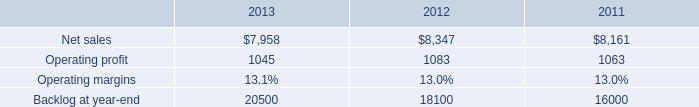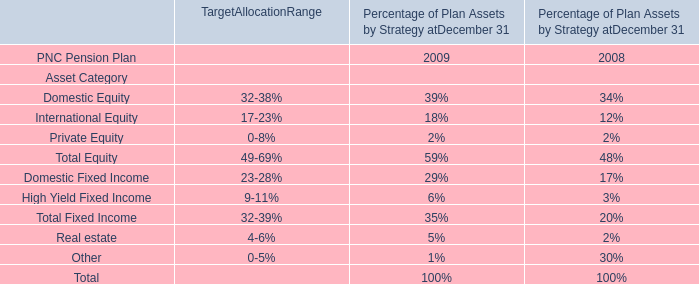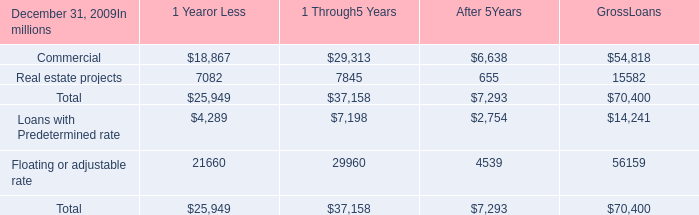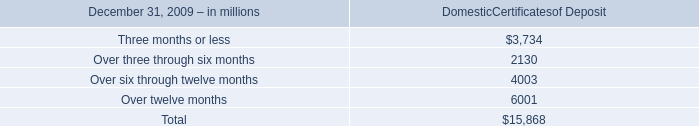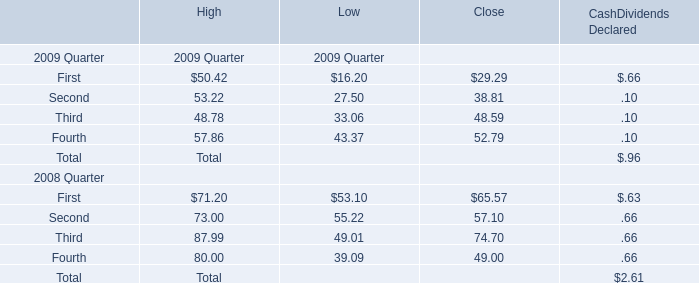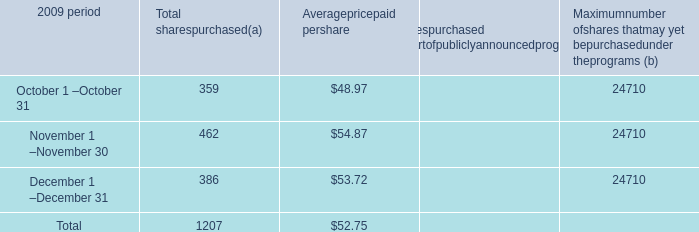What is the difference between 2008 and 2009 's highest First? 
Computations: (71.2 - 50.42)
Answer: 20.78. 